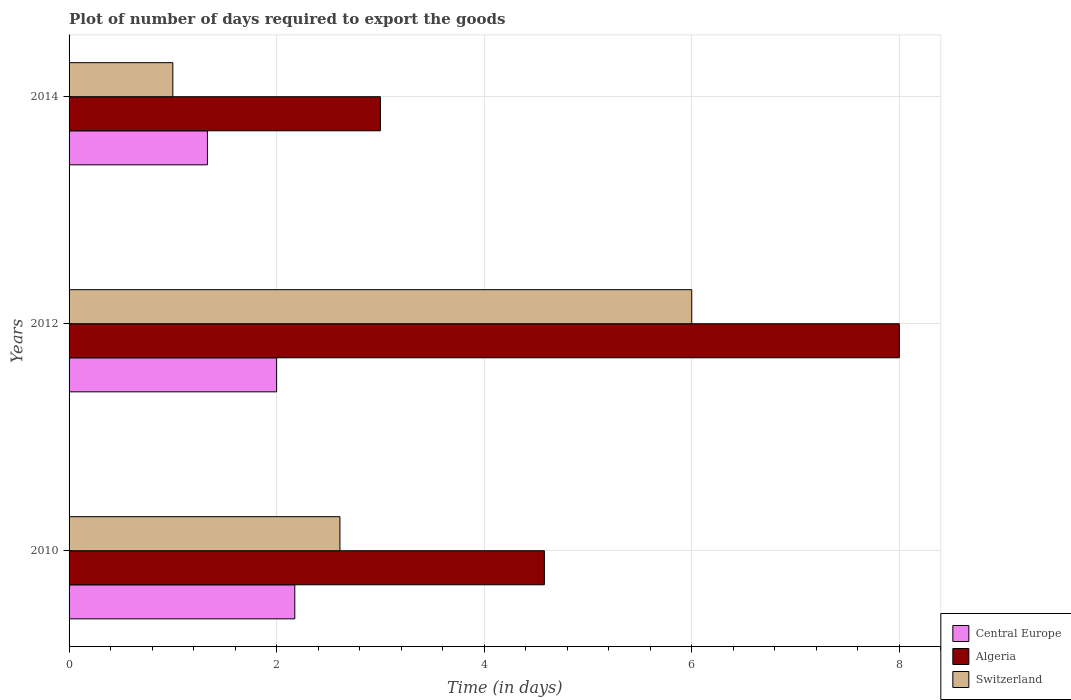How many groups of bars are there?
Make the answer very short. 3. Are the number of bars on each tick of the Y-axis equal?
Offer a terse response. Yes. Across all years, what is the maximum time required to export goods in Switzerland?
Ensure brevity in your answer.  6. Across all years, what is the minimum time required to export goods in Switzerland?
Make the answer very short. 1. In which year was the time required to export goods in Algeria maximum?
Offer a very short reply. 2012. What is the total time required to export goods in Central Europe in the graph?
Give a very brief answer. 5.51. What is the difference between the time required to export goods in Central Europe in 2010 and that in 2014?
Your answer should be compact. 0.84. What is the difference between the time required to export goods in Central Europe in 2010 and the time required to export goods in Algeria in 2012?
Provide a short and direct response. -5.83. What is the average time required to export goods in Algeria per year?
Give a very brief answer. 5.19. In the year 2010, what is the difference between the time required to export goods in Switzerland and time required to export goods in Algeria?
Make the answer very short. -1.97. What is the ratio of the time required to export goods in Algeria in 2012 to that in 2014?
Provide a succinct answer. 2.67. What is the difference between the highest and the second highest time required to export goods in Switzerland?
Keep it short and to the point. 3.39. What is the difference between the highest and the lowest time required to export goods in Switzerland?
Offer a very short reply. 5. In how many years, is the time required to export goods in Algeria greater than the average time required to export goods in Algeria taken over all years?
Provide a short and direct response. 1. What does the 2nd bar from the top in 2010 represents?
Ensure brevity in your answer.  Algeria. What does the 3rd bar from the bottom in 2014 represents?
Your answer should be very brief. Switzerland. Is it the case that in every year, the sum of the time required to export goods in Algeria and time required to export goods in Switzerland is greater than the time required to export goods in Central Europe?
Your response must be concise. Yes. Are all the bars in the graph horizontal?
Make the answer very short. Yes. Are the values on the major ticks of X-axis written in scientific E-notation?
Provide a short and direct response. No. Does the graph contain grids?
Your answer should be very brief. Yes. How many legend labels are there?
Ensure brevity in your answer.  3. How are the legend labels stacked?
Your answer should be compact. Vertical. What is the title of the graph?
Give a very brief answer. Plot of number of days required to export the goods. What is the label or title of the X-axis?
Make the answer very short. Time (in days). What is the Time (in days) in Central Europe in 2010?
Offer a terse response. 2.17. What is the Time (in days) in Algeria in 2010?
Your answer should be very brief. 4.58. What is the Time (in days) of Switzerland in 2010?
Ensure brevity in your answer.  2.61. What is the Time (in days) of Central Europe in 2012?
Provide a succinct answer. 2. What is the Time (in days) of Algeria in 2012?
Give a very brief answer. 8. What is the Time (in days) in Switzerland in 2012?
Keep it short and to the point. 6. What is the Time (in days) of Central Europe in 2014?
Your response must be concise. 1.33. What is the Time (in days) of Switzerland in 2014?
Offer a very short reply. 1. Across all years, what is the maximum Time (in days) of Central Europe?
Keep it short and to the point. 2.17. Across all years, what is the minimum Time (in days) of Central Europe?
Make the answer very short. 1.33. Across all years, what is the minimum Time (in days) of Algeria?
Give a very brief answer. 3. What is the total Time (in days) of Central Europe in the graph?
Your response must be concise. 5.51. What is the total Time (in days) in Algeria in the graph?
Make the answer very short. 15.58. What is the total Time (in days) in Switzerland in the graph?
Keep it short and to the point. 9.61. What is the difference between the Time (in days) in Central Europe in 2010 and that in 2012?
Provide a succinct answer. 0.17. What is the difference between the Time (in days) in Algeria in 2010 and that in 2012?
Your answer should be very brief. -3.42. What is the difference between the Time (in days) of Switzerland in 2010 and that in 2012?
Offer a very short reply. -3.39. What is the difference between the Time (in days) of Central Europe in 2010 and that in 2014?
Give a very brief answer. 0.84. What is the difference between the Time (in days) in Algeria in 2010 and that in 2014?
Offer a terse response. 1.58. What is the difference between the Time (in days) of Switzerland in 2010 and that in 2014?
Offer a very short reply. 1.61. What is the difference between the Time (in days) in Central Europe in 2012 and that in 2014?
Keep it short and to the point. 0.67. What is the difference between the Time (in days) of Switzerland in 2012 and that in 2014?
Your response must be concise. 5. What is the difference between the Time (in days) in Central Europe in 2010 and the Time (in days) in Algeria in 2012?
Provide a succinct answer. -5.83. What is the difference between the Time (in days) of Central Europe in 2010 and the Time (in days) of Switzerland in 2012?
Keep it short and to the point. -3.83. What is the difference between the Time (in days) of Algeria in 2010 and the Time (in days) of Switzerland in 2012?
Provide a succinct answer. -1.42. What is the difference between the Time (in days) of Central Europe in 2010 and the Time (in days) of Algeria in 2014?
Give a very brief answer. -0.82. What is the difference between the Time (in days) in Central Europe in 2010 and the Time (in days) in Switzerland in 2014?
Make the answer very short. 1.18. What is the difference between the Time (in days) in Algeria in 2010 and the Time (in days) in Switzerland in 2014?
Offer a terse response. 3.58. What is the difference between the Time (in days) in Central Europe in 2012 and the Time (in days) in Algeria in 2014?
Your answer should be very brief. -1. What is the average Time (in days) in Central Europe per year?
Offer a terse response. 1.84. What is the average Time (in days) of Algeria per year?
Your answer should be compact. 5.19. What is the average Time (in days) of Switzerland per year?
Provide a succinct answer. 3.2. In the year 2010, what is the difference between the Time (in days) of Central Europe and Time (in days) of Algeria?
Your response must be concise. -2.4. In the year 2010, what is the difference between the Time (in days) of Central Europe and Time (in days) of Switzerland?
Give a very brief answer. -0.43. In the year 2010, what is the difference between the Time (in days) in Algeria and Time (in days) in Switzerland?
Your answer should be compact. 1.97. In the year 2014, what is the difference between the Time (in days) of Central Europe and Time (in days) of Algeria?
Offer a terse response. -1.67. What is the ratio of the Time (in days) in Central Europe in 2010 to that in 2012?
Ensure brevity in your answer.  1.09. What is the ratio of the Time (in days) in Algeria in 2010 to that in 2012?
Offer a terse response. 0.57. What is the ratio of the Time (in days) in Switzerland in 2010 to that in 2012?
Give a very brief answer. 0.43. What is the ratio of the Time (in days) of Central Europe in 2010 to that in 2014?
Keep it short and to the point. 1.63. What is the ratio of the Time (in days) of Algeria in 2010 to that in 2014?
Offer a terse response. 1.53. What is the ratio of the Time (in days) of Switzerland in 2010 to that in 2014?
Your answer should be very brief. 2.61. What is the ratio of the Time (in days) in Central Europe in 2012 to that in 2014?
Provide a short and direct response. 1.5. What is the ratio of the Time (in days) of Algeria in 2012 to that in 2014?
Keep it short and to the point. 2.67. What is the difference between the highest and the second highest Time (in days) of Central Europe?
Provide a short and direct response. 0.17. What is the difference between the highest and the second highest Time (in days) of Algeria?
Give a very brief answer. 3.42. What is the difference between the highest and the second highest Time (in days) in Switzerland?
Offer a terse response. 3.39. What is the difference between the highest and the lowest Time (in days) of Central Europe?
Provide a succinct answer. 0.84. What is the difference between the highest and the lowest Time (in days) of Algeria?
Make the answer very short. 5. What is the difference between the highest and the lowest Time (in days) of Switzerland?
Keep it short and to the point. 5. 